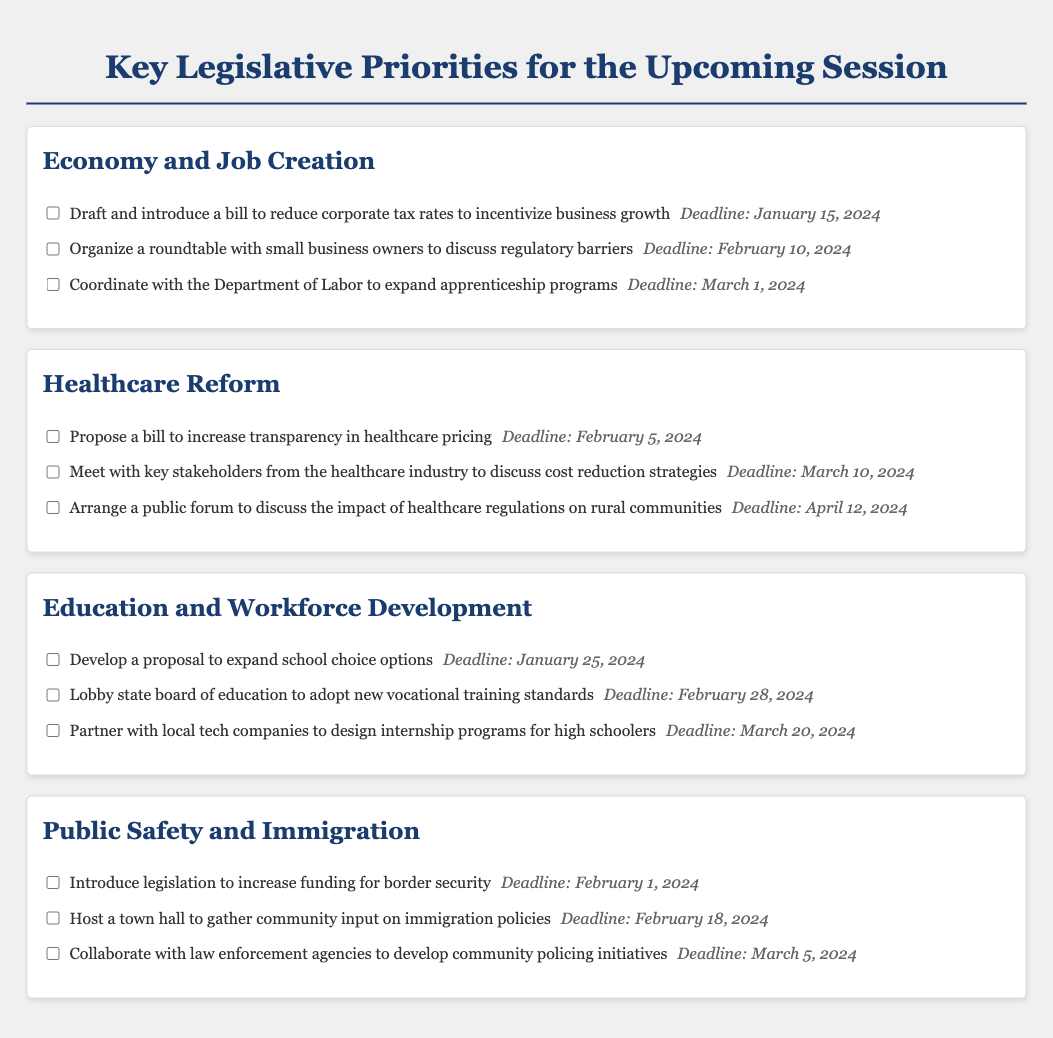What is the deadline for introducing a bill to reduce corporate tax rates? The deadline is clearly stated in the document next to the task regarding the bill on corporate tax rates.
Answer: January 15, 2024 How many tasks are listed under the Healthcare Reform priority? The number of tasks can be counted in the section dedicated to Healthcare Reform in the document.
Answer: Three What proposal is due by January 25, 2024? The document specifies a task proposal with a corresponding deadline within the Education and Workforce Development section.
Answer: Expand school choice options What is the main focus of the first task under Public Safety and Immigration? The document outlines the first task in that priority, which can be summarized as an introduction of legislation with a specific focus.
Answer: Increase funding for border security How many actions must be completed by the end of February 2024? To find this, count the tasks that have deadlines within February from all priorities listed in the document.
Answer: Four 